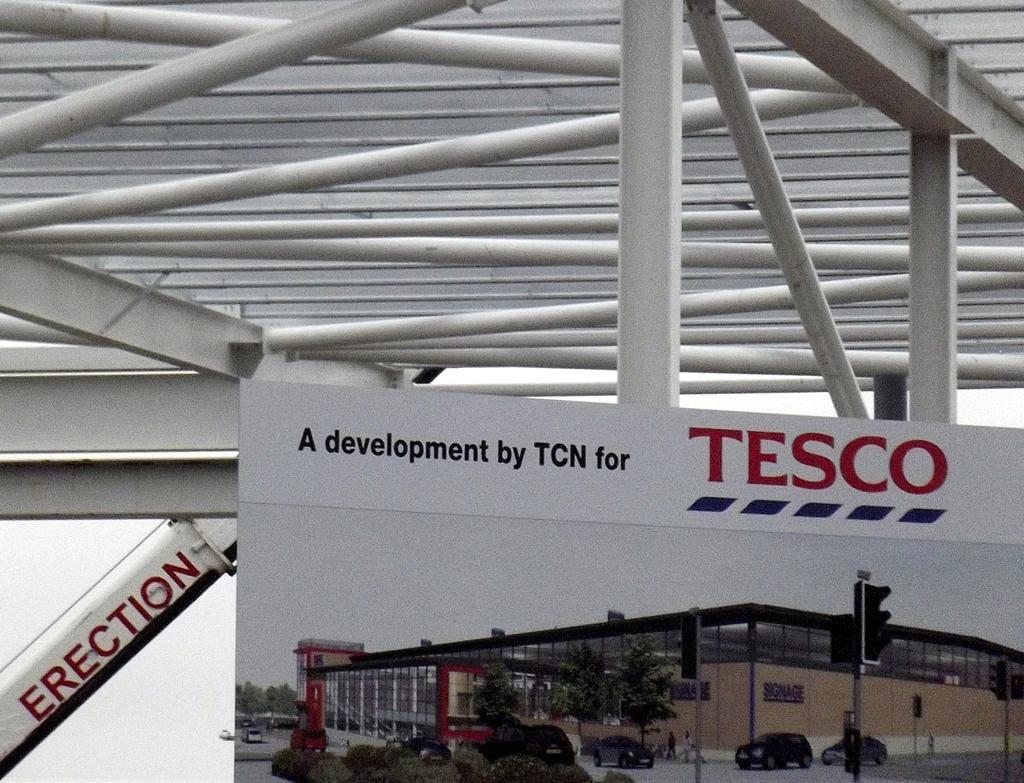Can you describe this image briefly? In this picture we can see banner poster in the front. Behind we can see white iron frames. 